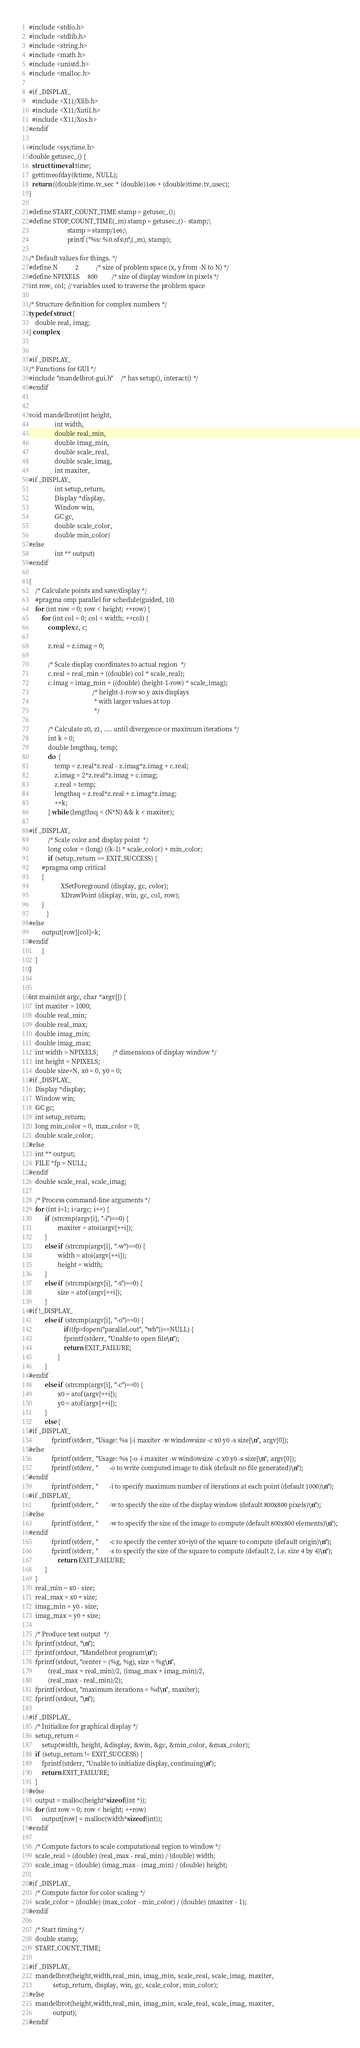<code> <loc_0><loc_0><loc_500><loc_500><_C_>
#include <stdio.h>
#include <stdlib.h>
#include <string.h>
#include <math.h>
#include <unistd.h>
#include <malloc.h>

#if _DISPLAY_
  #include <X11/Xlib.h>
  #include <X11/Xutil.h>
  #include <X11/Xos.h>
#endif

#include <sys/time.h>
double getusec_() {
  struct timeval time;
  gettimeofday(&time, NULL);
  return ((double)time.tv_sec * (double)1e6 + (double)time.tv_usec);
}

#define START_COUNT_TIME stamp = getusec_();
#define STOP_COUNT_TIME(_m) stamp = getusec_() - stamp;\
                        stamp = stamp/1e6;\
                        printf ("%s: %0.6fs\n",(_m), stamp);

/* Default values for things. */
#define N           2           /* size of problem space (x, y from -N to N) */
#define NPIXELS     800         /* size of display window in pixels */
int row, col; // variables used to traverse the problem space

/* Structure definition for complex numbers */
typedef struct {
    double real, imag;
} complex;


#if _DISPLAY_
/* Functions for GUI */
#include "mandelbrot-gui.h"     /* has setup(), interact() */
#endif


void mandelbrot(int height, 
                int width, 
                double real_min, 
                double imag_min,
                double scale_real, 
                double scale_imag, 
                int maxiter, 
#if _DISPLAY_
                int setup_return,
                Display *display, 
                Window win, 
                GC gc, 
                double scale_color,
                double min_color)
#else
                int ** output) 
#endif

{
    /* Calculate points and save/display */
    #pragma omp parallel for schedule(guided, 10)
    for (int row = 0; row < height; ++row) {
        for (int col = 0; col < width; ++col) {
            complex z, c;

            z.real = z.imag = 0;

            /* Scale display coordinates to actual region  */
            c.real = real_min + ((double) col * scale_real);
            c.imag = imag_min + ((double) (height-1-row) * scale_imag);
                                        /* height-1-row so y axis displays
                                         * with larger values at top
                                         */

            /* Calculate z0, z1, .... until divergence or maximum iterations */
            int k = 0;
            double lengthsq, temp;
            do  {
                temp = z.real*z.real - z.imag*z.imag + c.real;
                z.imag = 2*z.real*z.imag + c.imag;
                z.real = temp;
                lengthsq = z.real*z.real + z.imag*z.imag;
                ++k;
            } while (lengthsq < (N*N) && k < maxiter);

#if _DISPLAY_
            /* Scale color and display point  */
            long color = (long) ((k-1) * scale_color) + min_color;
            if (setup_return == EXIT_SUCCESS) {
		#pragma omp critical
		{
                	XSetForeground (display, gc, color);
                	XDrawPoint (display, win, gc, col, row);
		} 
           }
#else
	    output[row][col]=k;
#endif
        }
    }
}
            

int main(int argc, char *argv[]) {
    int maxiter = 1000;
    double real_min;
    double real_max;
    double imag_min;
    double imag_max;
    int width = NPIXELS;         /* dimensions of display window */
    int height = NPIXELS;
    double size=N, x0 = 0, y0 = 0;
#if _DISPLAY_
    Display *display;
    Window win;
    GC gc;
    int setup_return;
    long min_color = 0, max_color = 0;
    double scale_color;
#else 
    int ** output;
    FILE *fp = NULL;
#endif
    double scale_real, scale_imag;

    /* Process command-line arguments */
    for (int i=1; i<argc; i++) {
	      if (strcmp(argv[i], "-i")==0) {
			      maxiter = atoi(argv[++i]);
	      }
	      else if (strcmp(argv[i], "-w")==0) {
			      width = atoi(argv[++i]);
			      height = width;
	      }
	      else if (strcmp(argv[i], "-s")==0) {
			      size = atof(argv[++i]);
	      }
#if !_DISPLAY_
	      else if (strcmp(argv[i], "-o")==0) {
    			      if((fp=fopen("parallel.out", "wb"))==NULL) { 
				      fprintf(stderr, "Unable to open file\n"); 
				      return EXIT_FAILURE; 
			      }
	      }
#endif
	      else if (strcmp(argv[i], "-c")==0) {
			      x0 = atof(argv[++i]); 
			      y0 = atof(argv[++i]);
	      }
	      else {
#if _DISPLAY_
		      fprintf(stderr, "Usage: %s [-i maxiter -w windowsize -c x0 y0 -s size]\n", argv[0]);
#else
		      fprintf(stderr, "Usage: %s [-o -i maxiter -w windowsize -c x0 y0 -s size]\n", argv[0]);
		      fprintf(stderr, "       -o to write computed image to disk (default no file generated)\n");
#endif
		      fprintf(stderr, "       -i to specify maximum number of iterations at each point (default 1000)\n");
#if _DISPLAY_
		      fprintf(stderr, "       -w to specify the size of the display window (default 800x800 pixels)\n");
#else
		      fprintf(stderr, "       -w to specify the size of the image to compute (default 800x800 elements)\n");
#endif
		      fprintf(stderr, "       -c to specify the center x0+iy0 of the square to compute (default origin)\n");
		      fprintf(stderr, "       -s to specify the size of the square to compute (default 2, i.e. size 4 by 4)\n");
        	      return EXIT_FAILURE;
	      }
    }
    real_min = x0 - size;
    real_max = x0 + size;
    imag_min = y0 - size;
    imag_max = y0 + size;

    /* Produce text output  */
    fprintf(stdout, "\n");
    fprintf(stdout, "Mandelbrot program\n");
    fprintf(stdout, "center = (%g, %g), size = %g\n",
            (real_max + real_min)/2, (imag_max + imag_min)/2,
            (real_max - real_min)/2);
    fprintf(stdout, "maximum iterations = %d\n", maxiter);
    fprintf(stdout, "\n");

#if _DISPLAY_
    /* Initialize for graphical display */
    setup_return = 
        setup(width, height, &display, &win, &gc, &min_color, &max_color);
    if (setup_return != EXIT_SUCCESS) {
        fprintf(stderr, "Unable to initialize display, continuing\n");
        return EXIT_FAILURE;
    }
#else
    output = malloc(height*sizeof(int *));
    for (int row = 0; row < height; ++row)
	    output[row] = malloc(width*sizeof(int));
#endif

    /* Compute factors to scale computational region to window */
    scale_real = (double) (real_max - real_min) / (double) width;
    scale_imag = (double) (imag_max - imag_min) / (double) height;

#if _DISPLAY_
    /* Compute factor for color scaling */
    scale_color = (double) (max_color - min_color) / (double) (maxiter - 1);
#endif

    /* Start timing */
    double stamp;
    START_COUNT_TIME;

#if _DISPLAY_
    mandelbrot(height,width,real_min, imag_min, scale_real, scale_imag, maxiter, 
               setup_return, display, win, gc, scale_color, min_color); 
#else
    mandelbrot(height,width,real_min, imag_min, scale_real, scale_imag, maxiter, 
               output); 
#endif
</code> 